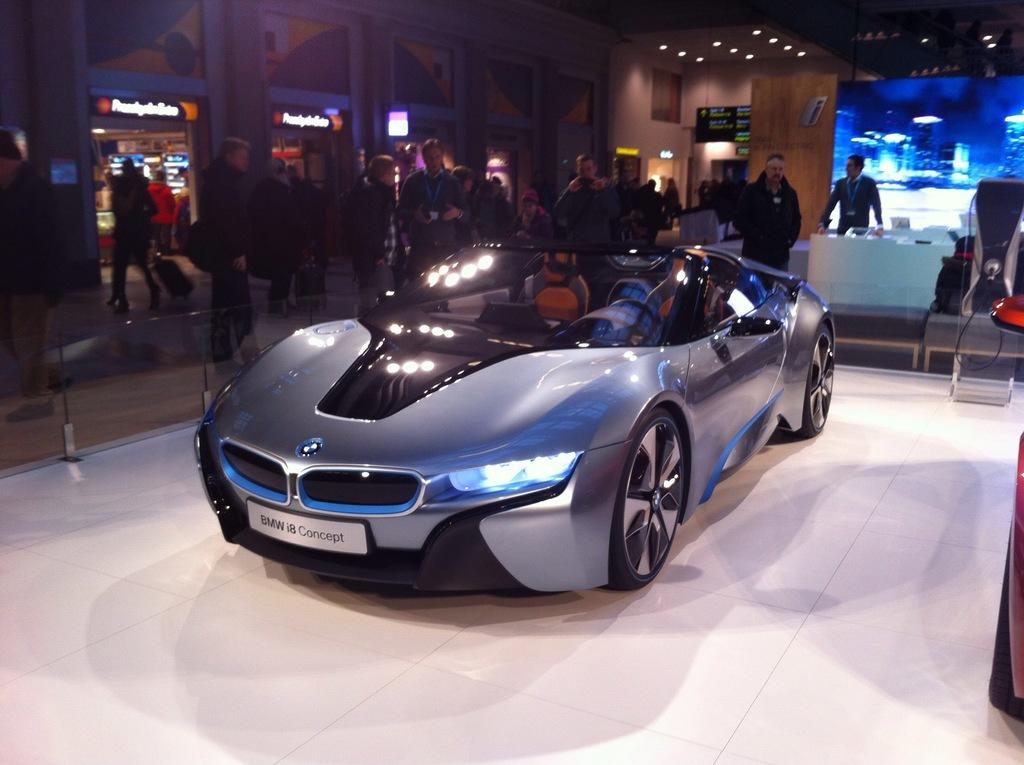What is the main subject of the picture? The main subject of the picture is a car. What is the car doing in the picture? The car is parked in the picture. Can you describe the background of the picture? There are people standing in the background of the picture. What is visible at the top of the picture? There is a roof visible in the top of the picture. What type of illumination is present in the image? There are lights present in the image. What type of berry can be seen growing on the car in the image? There is no berry growing on the car in the image; it is a parked car with no plants or fruits present. 